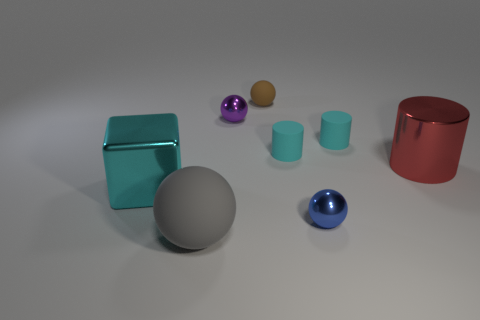Add 1 tiny brown metallic cubes. How many objects exist? 9 Subtract all blocks. How many objects are left? 7 Subtract 2 cyan cylinders. How many objects are left? 6 Subtract all tiny red metallic cubes. Subtract all rubber objects. How many objects are left? 4 Add 8 small purple spheres. How many small purple spheres are left? 9 Add 1 tiny cyan rubber objects. How many tiny cyan rubber objects exist? 3 